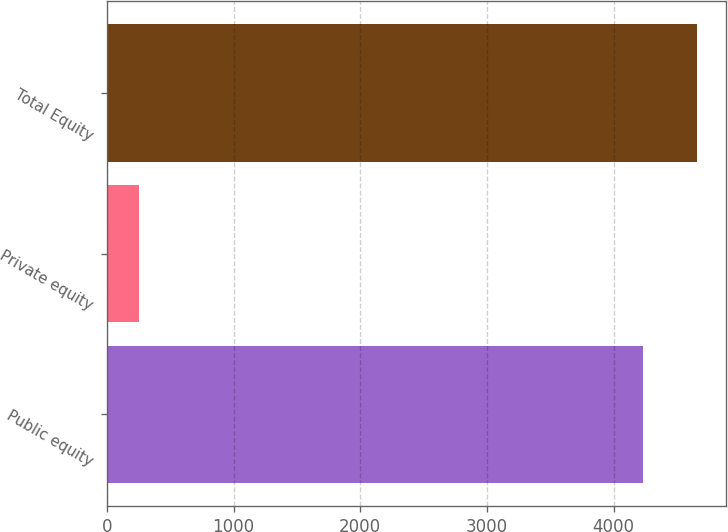<chart> <loc_0><loc_0><loc_500><loc_500><bar_chart><fcel>Public equity<fcel>Private equity<fcel>Total Equity<nl><fcel>4233<fcel>254<fcel>4656.3<nl></chart> 